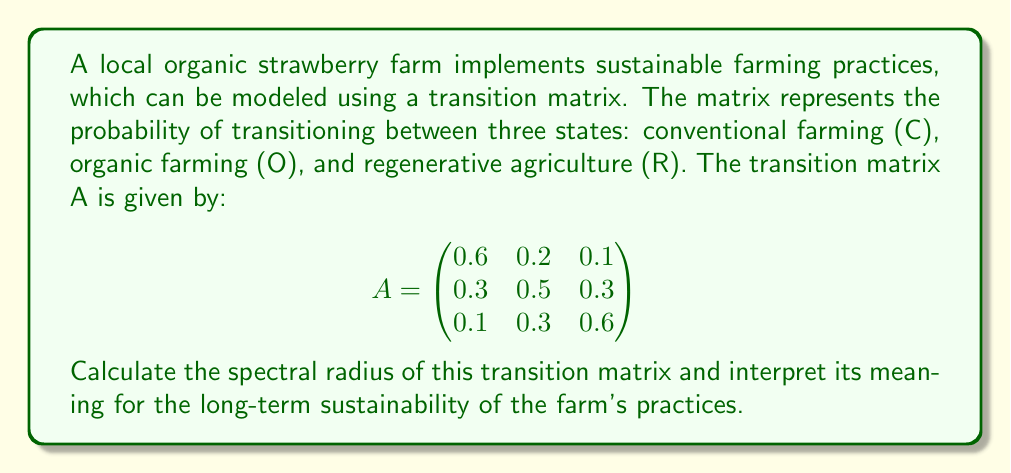Solve this math problem. To find the spectral radius of the transition matrix A, we need to follow these steps:

1. Calculate the eigenvalues of matrix A:
   - The characteristic equation is given by $\det(A - \lambda I) = 0$
   - Expanding this, we get:
     $$\begin{vmatrix}
     0.6-\lambda & 0.2 & 0.1 \\
     0.3 & 0.5-\lambda & 0.3 \\
     0.1 & 0.3 & 0.6-\lambda
     \end{vmatrix} = 0$$
   - This simplifies to:
     $-\lambda^3 + 1.7\lambda^2 - 0.83\lambda + 0.13 = 0$

2. Solve the characteristic equation:
   - Using numerical methods or a computer algebra system, we find the roots:
     $\lambda_1 \approx 1$, $\lambda_2 \approx 0.4$, $\lambda_3 \approx 0.3$

3. The spectral radius is the largest absolute value of the eigenvalues:
   $\rho(A) = \max(|\lambda_1|, |\lambda_2|, |\lambda_3|) = 1$

4. Interpretation:
   - The spectral radius being 1 indicates that the Markov chain is regular and has a unique stationary distribution.
   - This means that in the long run, the farm's practices will converge to a stable mix of conventional, organic, and regenerative agriculture.
   - The farm's overall sustainability is maintained, as there is no exponential growth or decay in any particular farming practice.
Answer: $\rho(A) = 1$, indicating long-term stability in sustainable farming practices. 